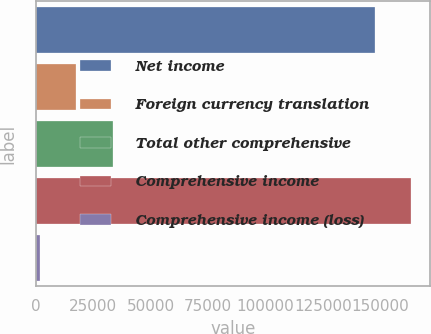Convert chart to OTSL. <chart><loc_0><loc_0><loc_500><loc_500><bar_chart><fcel>Net income<fcel>Foreign currency translation<fcel>Total other comprehensive<fcel>Comprehensive income<fcel>Comprehensive income (loss)<nl><fcel>147744<fcel>17638.2<fcel>33368.4<fcel>163474<fcel>1908<nl></chart> 